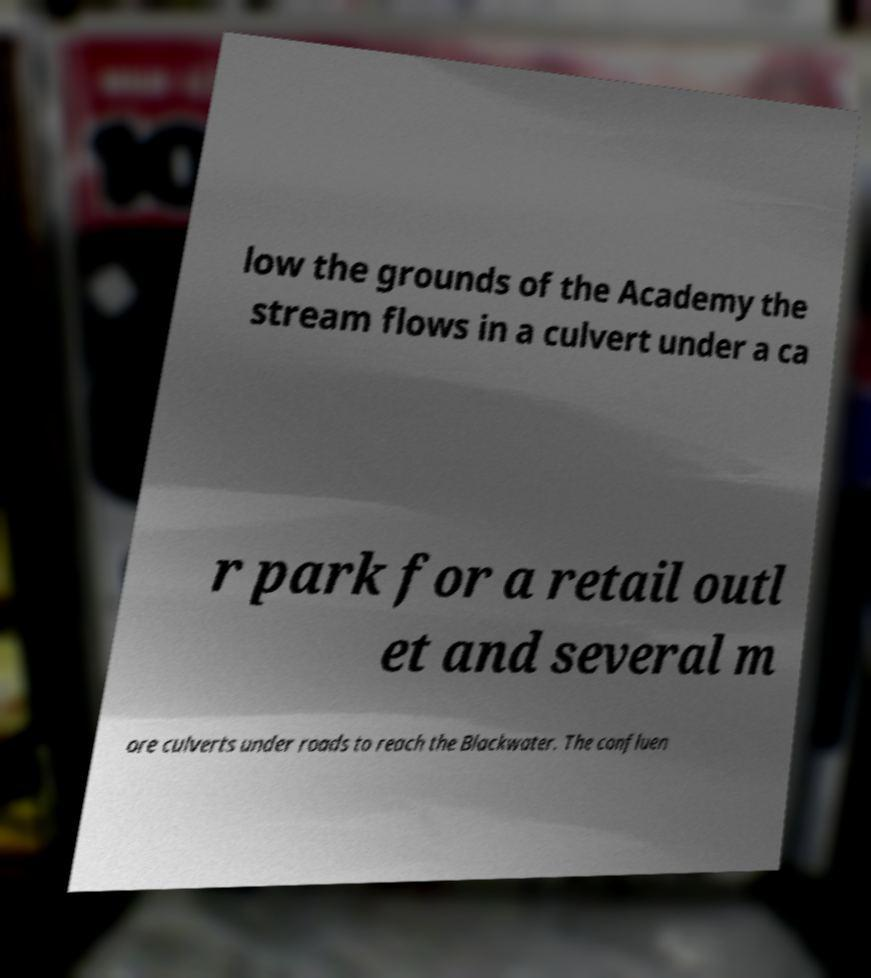Could you extract and type out the text from this image? low the grounds of the Academy the stream flows in a culvert under a ca r park for a retail outl et and several m ore culverts under roads to reach the Blackwater. The confluen 